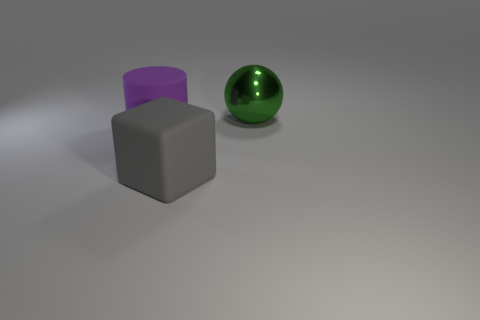Are there the same number of cylinders right of the gray rubber thing and big cylinders?
Offer a very short reply. No. Is the size of the matte cube the same as the object behind the big cylinder?
Your answer should be very brief. Yes. What number of other objects are there of the same size as the gray matte block?
Offer a terse response. 2. Is there any other thing that has the same size as the rubber cylinder?
Keep it short and to the point. Yes. What number of other things are the same shape as the gray rubber thing?
Your answer should be compact. 0. Do the shiny object and the gray matte cube have the same size?
Ensure brevity in your answer.  Yes. Are there any big metal things?
Give a very brief answer. Yes. Are there any other things that are made of the same material as the gray block?
Make the answer very short. Yes. Is there a gray cube that has the same material as the large green object?
Give a very brief answer. No. There is a gray object that is the same size as the cylinder; what is its material?
Provide a short and direct response. Rubber. 